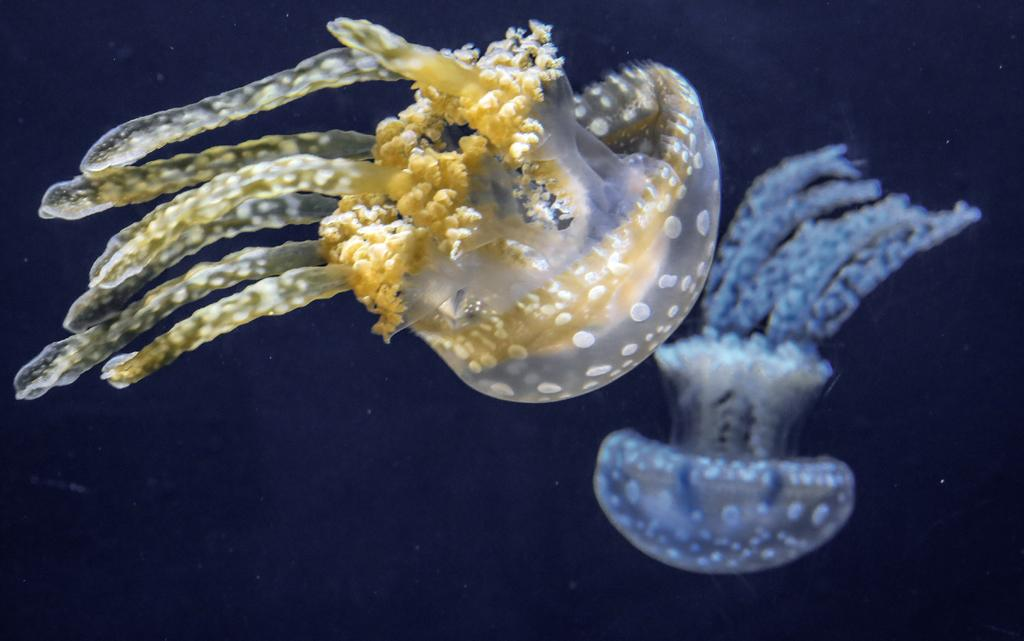What type of sea creatures are in the image? There are jellyfishes in the image. What can be observed about the background of the image? The background of the image is dark. What type of property is for sale in the image? There is no property for sale in the image; it features jellyfishes in a dark background. Can you tell me how many coaches are visible in the image? There are no coaches present in the image. 